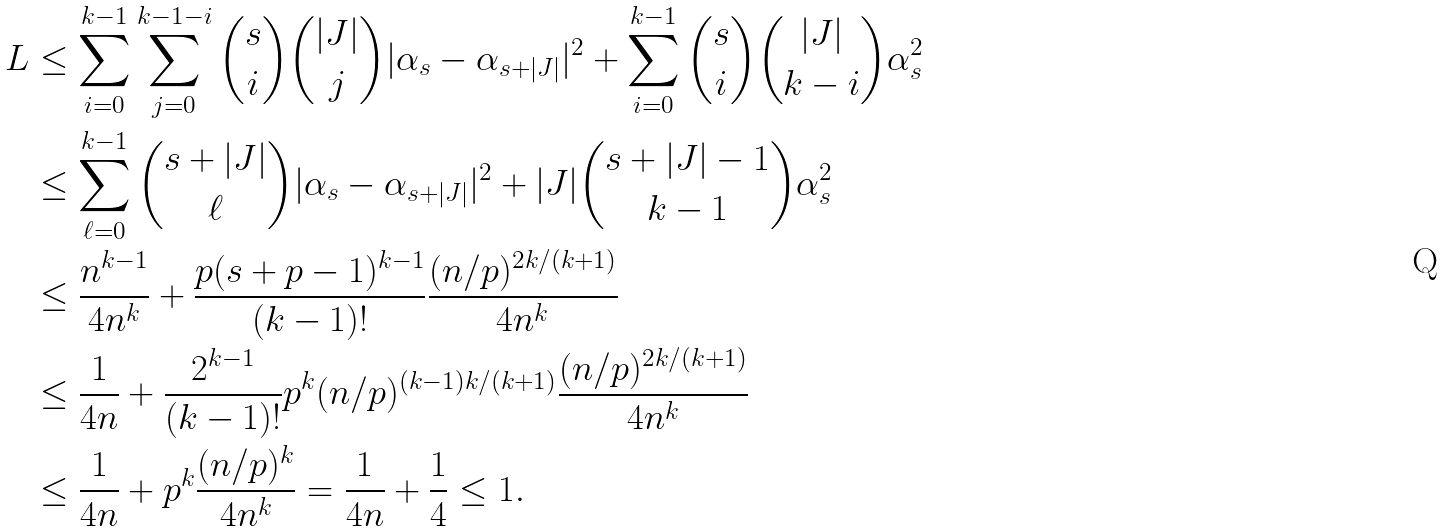Convert formula to latex. <formula><loc_0><loc_0><loc_500><loc_500>L & \leq \sum _ { i = 0 } ^ { k - 1 } \sum _ { j = 0 } ^ { k - 1 - i } { s \choose i } { | J | \choose j } | \alpha _ { s } - \alpha _ { s + | J | } | ^ { 2 } + \sum _ { i = 0 } ^ { k - 1 } { s \choose i } { | J | \choose k - i } \alpha _ { s } ^ { 2 } \\ & \leq \sum _ { \ell = 0 } ^ { k - 1 } { s + | J | \choose \ell } | \alpha _ { s } - \alpha _ { s + | J | } | ^ { 2 } + | J | { s + | J | - 1 \choose k - 1 } \alpha _ { s } ^ { 2 } \\ & \leq \frac { n ^ { k - 1 } } { 4 n ^ { k } } + \frac { p ( s + p - 1 ) ^ { k - 1 } } { ( k - 1 ) ! } \frac { ( n / p ) ^ { 2 k / ( k + 1 ) } } { 4 n ^ { k } } \\ & \leq \frac { 1 } { 4 n } + \frac { 2 ^ { k - 1 } } { ( k - 1 ) ! } p ^ { k } ( n / p ) ^ { ( k - 1 ) k / ( k + 1 ) } \frac { ( n / p ) ^ { 2 k / ( k + 1 ) } } { 4 n ^ { k } } \\ & \leq \frac { 1 } { 4 n } + p ^ { k } \frac { ( n / p ) ^ { k } } { 4 n ^ { k } } = \frac { 1 } { 4 n } + \frac { 1 } { 4 } \leq 1 .</formula> 